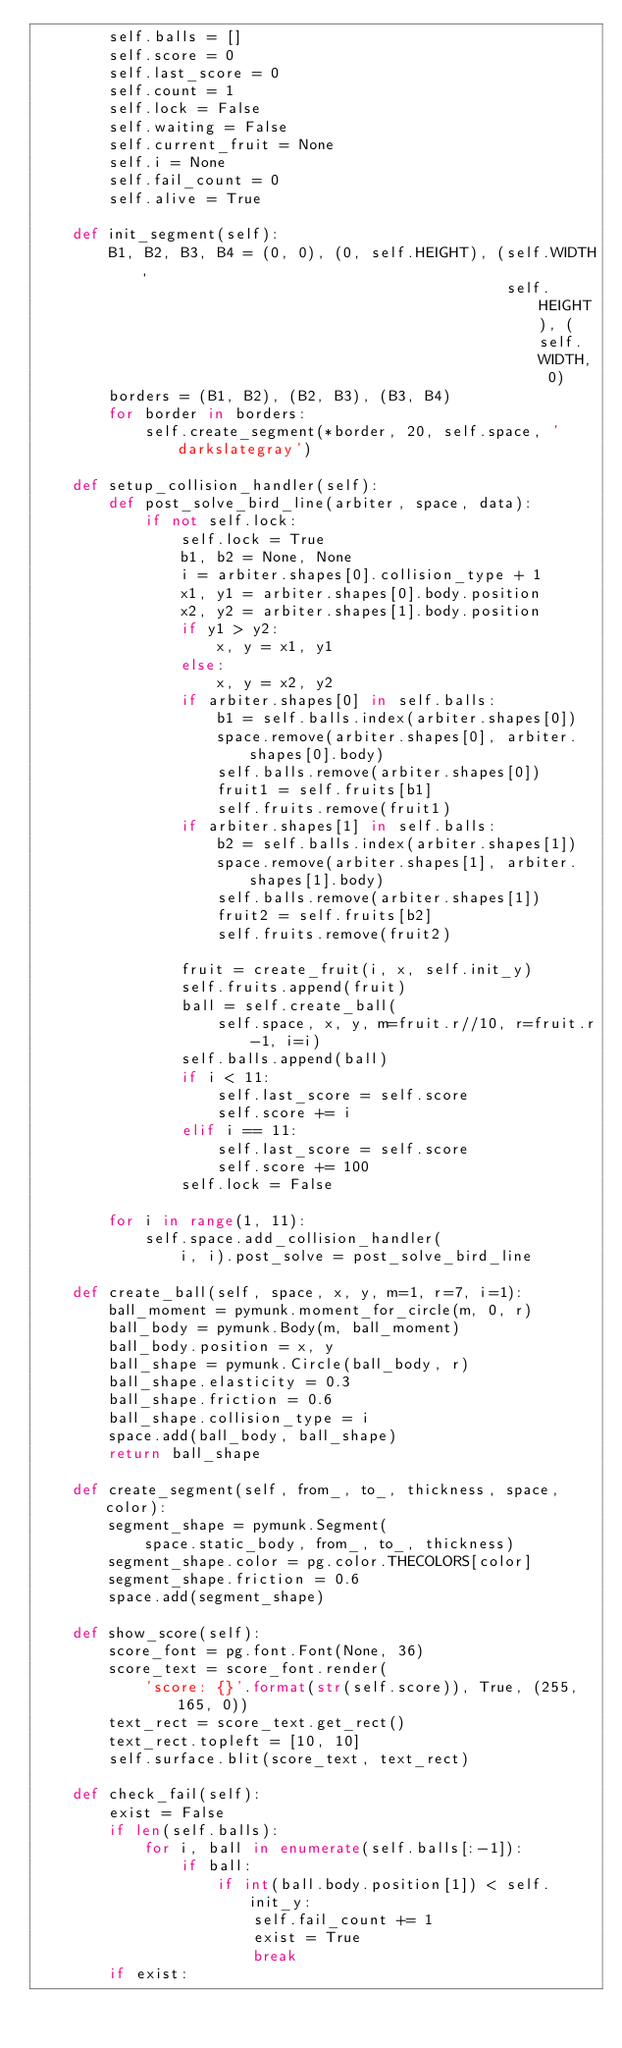Convert code to text. <code><loc_0><loc_0><loc_500><loc_500><_Python_>        self.balls = []
        self.score = 0
        self.last_score = 0
        self.count = 1
        self.lock = False
        self.waiting = False
        self.current_fruit = None
        self.i = None
        self.fail_count = 0
        self.alive = True

    def init_segment(self):
        B1, B2, B3, B4 = (0, 0), (0, self.HEIGHT), (self.WIDTH,
                                                    self.HEIGHT), (self.WIDTH, 0)
        borders = (B1, B2), (B2, B3), (B3, B4)
        for border in borders:
            self.create_segment(*border, 20, self.space, 'darkslategray')

    def setup_collision_handler(self):
        def post_solve_bird_line(arbiter, space, data):
            if not self.lock:
                self.lock = True
                b1, b2 = None, None
                i = arbiter.shapes[0].collision_type + 1
                x1, y1 = arbiter.shapes[0].body.position
                x2, y2 = arbiter.shapes[1].body.position
                if y1 > y2:
                    x, y = x1, y1
                else:
                    x, y = x2, y2
                if arbiter.shapes[0] in self.balls:
                    b1 = self.balls.index(arbiter.shapes[0])
                    space.remove(arbiter.shapes[0], arbiter.shapes[0].body)
                    self.balls.remove(arbiter.shapes[0])
                    fruit1 = self.fruits[b1]
                    self.fruits.remove(fruit1)
                if arbiter.shapes[1] in self.balls:
                    b2 = self.balls.index(arbiter.shapes[1])
                    space.remove(arbiter.shapes[1], arbiter.shapes[1].body)
                    self.balls.remove(arbiter.shapes[1])
                    fruit2 = self.fruits[b2]
                    self.fruits.remove(fruit2)

                fruit = create_fruit(i, x, self.init_y)
                self.fruits.append(fruit)
                ball = self.create_ball(
                    self.space, x, y, m=fruit.r//10, r=fruit.r-1, i=i)
                self.balls.append(ball)
                if i < 11:
                    self.last_score = self.score
                    self.score += i
                elif i == 11:
                    self.last_score = self.score
                    self.score += 100
                self.lock = False

        for i in range(1, 11):
            self.space.add_collision_handler(
                i, i).post_solve = post_solve_bird_line

    def create_ball(self, space, x, y, m=1, r=7, i=1):
        ball_moment = pymunk.moment_for_circle(m, 0, r)
        ball_body = pymunk.Body(m, ball_moment)
        ball_body.position = x, y
        ball_shape = pymunk.Circle(ball_body, r)
        ball_shape.elasticity = 0.3
        ball_shape.friction = 0.6
        ball_shape.collision_type = i
        space.add(ball_body, ball_shape)
        return ball_shape

    def create_segment(self, from_, to_, thickness, space, color):
        segment_shape = pymunk.Segment(
            space.static_body, from_, to_, thickness)
        segment_shape.color = pg.color.THECOLORS[color]
        segment_shape.friction = 0.6
        space.add(segment_shape)

    def show_score(self):
        score_font = pg.font.Font(None, 36)
        score_text = score_font.render(
            'score: {}'.format(str(self.score)), True, (255, 165, 0))
        text_rect = score_text.get_rect()
        text_rect.topleft = [10, 10]
        self.surface.blit(score_text, text_rect)

    def check_fail(self):
        exist = False
        if len(self.balls):
            for i, ball in enumerate(self.balls[:-1]):
                if ball:
                    if int(ball.body.position[1]) < self.init_y:
                        self.fail_count += 1
                        exist = True
                        break
        if exist:</code> 